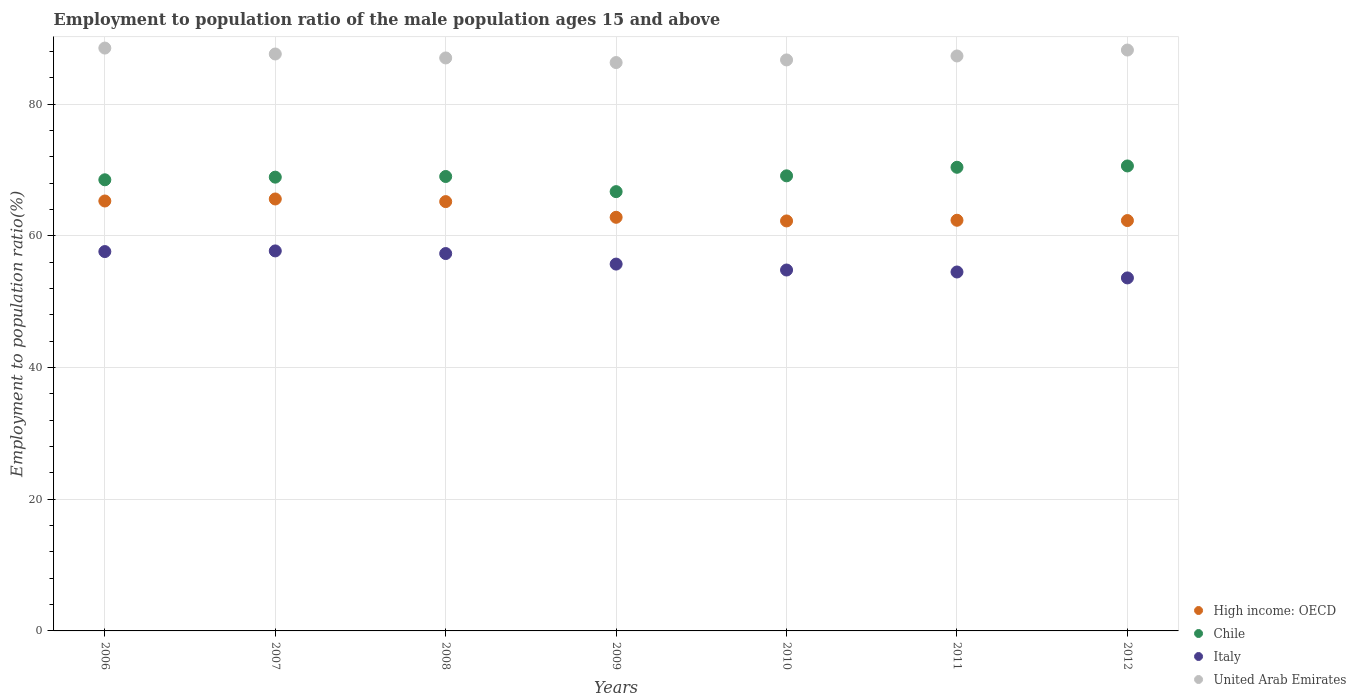Is the number of dotlines equal to the number of legend labels?
Offer a terse response. Yes. What is the employment to population ratio in High income: OECD in 2012?
Offer a very short reply. 62.31. Across all years, what is the maximum employment to population ratio in Italy?
Keep it short and to the point. 57.7. Across all years, what is the minimum employment to population ratio in Italy?
Offer a terse response. 53.6. What is the total employment to population ratio in Italy in the graph?
Ensure brevity in your answer.  391.2. What is the difference between the employment to population ratio in High income: OECD in 2007 and that in 2010?
Give a very brief answer. 3.33. What is the difference between the employment to population ratio in High income: OECD in 2009 and the employment to population ratio in United Arab Emirates in 2008?
Offer a terse response. -24.2. What is the average employment to population ratio in High income: OECD per year?
Give a very brief answer. 63.68. In the year 2012, what is the difference between the employment to population ratio in Italy and employment to population ratio in Chile?
Provide a short and direct response. -17. In how many years, is the employment to population ratio in Italy greater than 8 %?
Your response must be concise. 7. What is the ratio of the employment to population ratio in High income: OECD in 2007 to that in 2009?
Your response must be concise. 1.04. Is the difference between the employment to population ratio in Italy in 2009 and 2010 greater than the difference between the employment to population ratio in Chile in 2009 and 2010?
Give a very brief answer. Yes. What is the difference between the highest and the second highest employment to population ratio in Italy?
Keep it short and to the point. 0.1. What is the difference between the highest and the lowest employment to population ratio in High income: OECD?
Your answer should be compact. 3.33. Is the employment to population ratio in Italy strictly less than the employment to population ratio in United Arab Emirates over the years?
Your answer should be compact. Yes. How many dotlines are there?
Give a very brief answer. 4. How many years are there in the graph?
Make the answer very short. 7. What is the difference between two consecutive major ticks on the Y-axis?
Provide a short and direct response. 20. Are the values on the major ticks of Y-axis written in scientific E-notation?
Ensure brevity in your answer.  No. How many legend labels are there?
Your answer should be very brief. 4. What is the title of the graph?
Your response must be concise. Employment to population ratio of the male population ages 15 and above. Does "Netherlands" appear as one of the legend labels in the graph?
Your answer should be very brief. No. What is the label or title of the X-axis?
Ensure brevity in your answer.  Years. What is the label or title of the Y-axis?
Give a very brief answer. Employment to population ratio(%). What is the Employment to population ratio(%) in High income: OECD in 2006?
Offer a very short reply. 65.28. What is the Employment to population ratio(%) of Chile in 2006?
Provide a succinct answer. 68.5. What is the Employment to population ratio(%) in Italy in 2006?
Your answer should be compact. 57.6. What is the Employment to population ratio(%) of United Arab Emirates in 2006?
Make the answer very short. 88.5. What is the Employment to population ratio(%) in High income: OECD in 2007?
Your answer should be compact. 65.59. What is the Employment to population ratio(%) of Chile in 2007?
Provide a succinct answer. 68.9. What is the Employment to population ratio(%) of Italy in 2007?
Keep it short and to the point. 57.7. What is the Employment to population ratio(%) of United Arab Emirates in 2007?
Offer a terse response. 87.6. What is the Employment to population ratio(%) of High income: OECD in 2008?
Your answer should be very brief. 65.19. What is the Employment to population ratio(%) in Italy in 2008?
Offer a terse response. 57.3. What is the Employment to population ratio(%) in United Arab Emirates in 2008?
Make the answer very short. 87. What is the Employment to population ratio(%) of High income: OECD in 2009?
Offer a very short reply. 62.8. What is the Employment to population ratio(%) of Chile in 2009?
Give a very brief answer. 66.7. What is the Employment to population ratio(%) in Italy in 2009?
Offer a very short reply. 55.7. What is the Employment to population ratio(%) of United Arab Emirates in 2009?
Offer a very short reply. 86.3. What is the Employment to population ratio(%) of High income: OECD in 2010?
Provide a succinct answer. 62.25. What is the Employment to population ratio(%) of Chile in 2010?
Your answer should be compact. 69.1. What is the Employment to population ratio(%) in Italy in 2010?
Your response must be concise. 54.8. What is the Employment to population ratio(%) in United Arab Emirates in 2010?
Provide a succinct answer. 86.7. What is the Employment to population ratio(%) in High income: OECD in 2011?
Provide a short and direct response. 62.35. What is the Employment to population ratio(%) in Chile in 2011?
Ensure brevity in your answer.  70.4. What is the Employment to population ratio(%) in Italy in 2011?
Offer a very short reply. 54.5. What is the Employment to population ratio(%) in United Arab Emirates in 2011?
Ensure brevity in your answer.  87.3. What is the Employment to population ratio(%) in High income: OECD in 2012?
Give a very brief answer. 62.31. What is the Employment to population ratio(%) of Chile in 2012?
Provide a succinct answer. 70.6. What is the Employment to population ratio(%) in Italy in 2012?
Provide a succinct answer. 53.6. What is the Employment to population ratio(%) of United Arab Emirates in 2012?
Your response must be concise. 88.2. Across all years, what is the maximum Employment to population ratio(%) in High income: OECD?
Keep it short and to the point. 65.59. Across all years, what is the maximum Employment to population ratio(%) in Chile?
Provide a succinct answer. 70.6. Across all years, what is the maximum Employment to population ratio(%) in Italy?
Keep it short and to the point. 57.7. Across all years, what is the maximum Employment to population ratio(%) of United Arab Emirates?
Offer a very short reply. 88.5. Across all years, what is the minimum Employment to population ratio(%) in High income: OECD?
Make the answer very short. 62.25. Across all years, what is the minimum Employment to population ratio(%) of Chile?
Provide a succinct answer. 66.7. Across all years, what is the minimum Employment to population ratio(%) of Italy?
Make the answer very short. 53.6. Across all years, what is the minimum Employment to population ratio(%) in United Arab Emirates?
Your response must be concise. 86.3. What is the total Employment to population ratio(%) of High income: OECD in the graph?
Make the answer very short. 445.77. What is the total Employment to population ratio(%) of Chile in the graph?
Provide a succinct answer. 483.2. What is the total Employment to population ratio(%) in Italy in the graph?
Your answer should be very brief. 391.2. What is the total Employment to population ratio(%) of United Arab Emirates in the graph?
Keep it short and to the point. 611.6. What is the difference between the Employment to population ratio(%) in High income: OECD in 2006 and that in 2007?
Offer a terse response. -0.31. What is the difference between the Employment to population ratio(%) of Chile in 2006 and that in 2007?
Offer a very short reply. -0.4. What is the difference between the Employment to population ratio(%) in Italy in 2006 and that in 2007?
Offer a terse response. -0.1. What is the difference between the Employment to population ratio(%) of United Arab Emirates in 2006 and that in 2007?
Give a very brief answer. 0.9. What is the difference between the Employment to population ratio(%) in High income: OECD in 2006 and that in 2008?
Provide a succinct answer. 0.09. What is the difference between the Employment to population ratio(%) of High income: OECD in 2006 and that in 2009?
Give a very brief answer. 2.48. What is the difference between the Employment to population ratio(%) in Italy in 2006 and that in 2009?
Offer a very short reply. 1.9. What is the difference between the Employment to population ratio(%) in United Arab Emirates in 2006 and that in 2009?
Your response must be concise. 2.2. What is the difference between the Employment to population ratio(%) of High income: OECD in 2006 and that in 2010?
Keep it short and to the point. 3.03. What is the difference between the Employment to population ratio(%) of Italy in 2006 and that in 2010?
Your answer should be very brief. 2.8. What is the difference between the Employment to population ratio(%) of United Arab Emirates in 2006 and that in 2010?
Your response must be concise. 1.8. What is the difference between the Employment to population ratio(%) in High income: OECD in 2006 and that in 2011?
Your answer should be compact. 2.93. What is the difference between the Employment to population ratio(%) of Chile in 2006 and that in 2011?
Give a very brief answer. -1.9. What is the difference between the Employment to population ratio(%) of Italy in 2006 and that in 2011?
Your response must be concise. 3.1. What is the difference between the Employment to population ratio(%) in United Arab Emirates in 2006 and that in 2011?
Offer a very short reply. 1.2. What is the difference between the Employment to population ratio(%) in High income: OECD in 2006 and that in 2012?
Your answer should be very brief. 2.97. What is the difference between the Employment to population ratio(%) of Italy in 2006 and that in 2012?
Offer a very short reply. 4. What is the difference between the Employment to population ratio(%) of United Arab Emirates in 2006 and that in 2012?
Offer a terse response. 0.3. What is the difference between the Employment to population ratio(%) of High income: OECD in 2007 and that in 2008?
Offer a very short reply. 0.4. What is the difference between the Employment to population ratio(%) of Italy in 2007 and that in 2008?
Ensure brevity in your answer.  0.4. What is the difference between the Employment to population ratio(%) in United Arab Emirates in 2007 and that in 2008?
Your response must be concise. 0.6. What is the difference between the Employment to population ratio(%) of High income: OECD in 2007 and that in 2009?
Keep it short and to the point. 2.78. What is the difference between the Employment to population ratio(%) of Chile in 2007 and that in 2009?
Offer a terse response. 2.2. What is the difference between the Employment to population ratio(%) in High income: OECD in 2007 and that in 2010?
Provide a succinct answer. 3.33. What is the difference between the Employment to population ratio(%) of Italy in 2007 and that in 2010?
Your answer should be compact. 2.9. What is the difference between the Employment to population ratio(%) in United Arab Emirates in 2007 and that in 2010?
Offer a very short reply. 0.9. What is the difference between the Employment to population ratio(%) of High income: OECD in 2007 and that in 2011?
Give a very brief answer. 3.23. What is the difference between the Employment to population ratio(%) in United Arab Emirates in 2007 and that in 2011?
Ensure brevity in your answer.  0.3. What is the difference between the Employment to population ratio(%) in High income: OECD in 2007 and that in 2012?
Offer a very short reply. 3.28. What is the difference between the Employment to population ratio(%) in Chile in 2007 and that in 2012?
Keep it short and to the point. -1.7. What is the difference between the Employment to population ratio(%) in United Arab Emirates in 2007 and that in 2012?
Your answer should be very brief. -0.6. What is the difference between the Employment to population ratio(%) in High income: OECD in 2008 and that in 2009?
Keep it short and to the point. 2.38. What is the difference between the Employment to population ratio(%) of High income: OECD in 2008 and that in 2010?
Provide a short and direct response. 2.94. What is the difference between the Employment to population ratio(%) of Italy in 2008 and that in 2010?
Your response must be concise. 2.5. What is the difference between the Employment to population ratio(%) in High income: OECD in 2008 and that in 2011?
Your answer should be compact. 2.83. What is the difference between the Employment to population ratio(%) in Chile in 2008 and that in 2011?
Give a very brief answer. -1.4. What is the difference between the Employment to population ratio(%) of Italy in 2008 and that in 2011?
Make the answer very short. 2.8. What is the difference between the Employment to population ratio(%) in United Arab Emirates in 2008 and that in 2011?
Your response must be concise. -0.3. What is the difference between the Employment to population ratio(%) of High income: OECD in 2008 and that in 2012?
Make the answer very short. 2.88. What is the difference between the Employment to population ratio(%) of Chile in 2008 and that in 2012?
Give a very brief answer. -1.6. What is the difference between the Employment to population ratio(%) in High income: OECD in 2009 and that in 2010?
Offer a terse response. 0.55. What is the difference between the Employment to population ratio(%) in Italy in 2009 and that in 2010?
Provide a short and direct response. 0.9. What is the difference between the Employment to population ratio(%) of High income: OECD in 2009 and that in 2011?
Give a very brief answer. 0.45. What is the difference between the Employment to population ratio(%) of High income: OECD in 2009 and that in 2012?
Ensure brevity in your answer.  0.5. What is the difference between the Employment to population ratio(%) of Chile in 2009 and that in 2012?
Ensure brevity in your answer.  -3.9. What is the difference between the Employment to population ratio(%) in High income: OECD in 2010 and that in 2011?
Keep it short and to the point. -0.1. What is the difference between the Employment to population ratio(%) in High income: OECD in 2010 and that in 2012?
Your answer should be compact. -0.06. What is the difference between the Employment to population ratio(%) in Chile in 2010 and that in 2012?
Provide a succinct answer. -1.5. What is the difference between the Employment to population ratio(%) in High income: OECD in 2011 and that in 2012?
Offer a terse response. 0.04. What is the difference between the Employment to population ratio(%) of Italy in 2011 and that in 2012?
Your response must be concise. 0.9. What is the difference between the Employment to population ratio(%) in High income: OECD in 2006 and the Employment to population ratio(%) in Chile in 2007?
Give a very brief answer. -3.62. What is the difference between the Employment to population ratio(%) of High income: OECD in 2006 and the Employment to population ratio(%) of Italy in 2007?
Offer a terse response. 7.58. What is the difference between the Employment to population ratio(%) in High income: OECD in 2006 and the Employment to population ratio(%) in United Arab Emirates in 2007?
Offer a very short reply. -22.32. What is the difference between the Employment to population ratio(%) in Chile in 2006 and the Employment to population ratio(%) in United Arab Emirates in 2007?
Your response must be concise. -19.1. What is the difference between the Employment to population ratio(%) of High income: OECD in 2006 and the Employment to population ratio(%) of Chile in 2008?
Keep it short and to the point. -3.72. What is the difference between the Employment to population ratio(%) of High income: OECD in 2006 and the Employment to population ratio(%) of Italy in 2008?
Keep it short and to the point. 7.98. What is the difference between the Employment to population ratio(%) in High income: OECD in 2006 and the Employment to population ratio(%) in United Arab Emirates in 2008?
Give a very brief answer. -21.72. What is the difference between the Employment to population ratio(%) of Chile in 2006 and the Employment to population ratio(%) of United Arab Emirates in 2008?
Give a very brief answer. -18.5. What is the difference between the Employment to population ratio(%) in Italy in 2006 and the Employment to population ratio(%) in United Arab Emirates in 2008?
Your response must be concise. -29.4. What is the difference between the Employment to population ratio(%) in High income: OECD in 2006 and the Employment to population ratio(%) in Chile in 2009?
Your answer should be very brief. -1.42. What is the difference between the Employment to population ratio(%) in High income: OECD in 2006 and the Employment to population ratio(%) in Italy in 2009?
Provide a succinct answer. 9.58. What is the difference between the Employment to population ratio(%) in High income: OECD in 2006 and the Employment to population ratio(%) in United Arab Emirates in 2009?
Offer a very short reply. -21.02. What is the difference between the Employment to population ratio(%) of Chile in 2006 and the Employment to population ratio(%) of United Arab Emirates in 2009?
Offer a very short reply. -17.8. What is the difference between the Employment to population ratio(%) of Italy in 2006 and the Employment to population ratio(%) of United Arab Emirates in 2009?
Offer a very short reply. -28.7. What is the difference between the Employment to population ratio(%) of High income: OECD in 2006 and the Employment to population ratio(%) of Chile in 2010?
Offer a very short reply. -3.82. What is the difference between the Employment to population ratio(%) of High income: OECD in 2006 and the Employment to population ratio(%) of Italy in 2010?
Give a very brief answer. 10.48. What is the difference between the Employment to population ratio(%) in High income: OECD in 2006 and the Employment to population ratio(%) in United Arab Emirates in 2010?
Your answer should be compact. -21.42. What is the difference between the Employment to population ratio(%) in Chile in 2006 and the Employment to population ratio(%) in Italy in 2010?
Your answer should be very brief. 13.7. What is the difference between the Employment to population ratio(%) of Chile in 2006 and the Employment to population ratio(%) of United Arab Emirates in 2010?
Your answer should be compact. -18.2. What is the difference between the Employment to population ratio(%) of Italy in 2006 and the Employment to population ratio(%) of United Arab Emirates in 2010?
Make the answer very short. -29.1. What is the difference between the Employment to population ratio(%) in High income: OECD in 2006 and the Employment to population ratio(%) in Chile in 2011?
Give a very brief answer. -5.12. What is the difference between the Employment to population ratio(%) in High income: OECD in 2006 and the Employment to population ratio(%) in Italy in 2011?
Offer a very short reply. 10.78. What is the difference between the Employment to population ratio(%) of High income: OECD in 2006 and the Employment to population ratio(%) of United Arab Emirates in 2011?
Your response must be concise. -22.02. What is the difference between the Employment to population ratio(%) of Chile in 2006 and the Employment to population ratio(%) of Italy in 2011?
Offer a terse response. 14. What is the difference between the Employment to population ratio(%) in Chile in 2006 and the Employment to population ratio(%) in United Arab Emirates in 2011?
Offer a very short reply. -18.8. What is the difference between the Employment to population ratio(%) of Italy in 2006 and the Employment to population ratio(%) of United Arab Emirates in 2011?
Make the answer very short. -29.7. What is the difference between the Employment to population ratio(%) of High income: OECD in 2006 and the Employment to population ratio(%) of Chile in 2012?
Keep it short and to the point. -5.32. What is the difference between the Employment to population ratio(%) of High income: OECD in 2006 and the Employment to population ratio(%) of Italy in 2012?
Make the answer very short. 11.68. What is the difference between the Employment to population ratio(%) of High income: OECD in 2006 and the Employment to population ratio(%) of United Arab Emirates in 2012?
Provide a short and direct response. -22.92. What is the difference between the Employment to population ratio(%) in Chile in 2006 and the Employment to population ratio(%) in United Arab Emirates in 2012?
Offer a terse response. -19.7. What is the difference between the Employment to population ratio(%) in Italy in 2006 and the Employment to population ratio(%) in United Arab Emirates in 2012?
Ensure brevity in your answer.  -30.6. What is the difference between the Employment to population ratio(%) of High income: OECD in 2007 and the Employment to population ratio(%) of Chile in 2008?
Offer a terse response. -3.41. What is the difference between the Employment to population ratio(%) of High income: OECD in 2007 and the Employment to population ratio(%) of Italy in 2008?
Make the answer very short. 8.29. What is the difference between the Employment to population ratio(%) of High income: OECD in 2007 and the Employment to population ratio(%) of United Arab Emirates in 2008?
Your response must be concise. -21.41. What is the difference between the Employment to population ratio(%) of Chile in 2007 and the Employment to population ratio(%) of Italy in 2008?
Make the answer very short. 11.6. What is the difference between the Employment to population ratio(%) in Chile in 2007 and the Employment to population ratio(%) in United Arab Emirates in 2008?
Provide a short and direct response. -18.1. What is the difference between the Employment to population ratio(%) of Italy in 2007 and the Employment to population ratio(%) of United Arab Emirates in 2008?
Offer a very short reply. -29.3. What is the difference between the Employment to population ratio(%) in High income: OECD in 2007 and the Employment to population ratio(%) in Chile in 2009?
Provide a succinct answer. -1.11. What is the difference between the Employment to population ratio(%) in High income: OECD in 2007 and the Employment to population ratio(%) in Italy in 2009?
Offer a terse response. 9.89. What is the difference between the Employment to population ratio(%) in High income: OECD in 2007 and the Employment to population ratio(%) in United Arab Emirates in 2009?
Keep it short and to the point. -20.71. What is the difference between the Employment to population ratio(%) in Chile in 2007 and the Employment to population ratio(%) in Italy in 2009?
Keep it short and to the point. 13.2. What is the difference between the Employment to population ratio(%) of Chile in 2007 and the Employment to population ratio(%) of United Arab Emirates in 2009?
Offer a terse response. -17.4. What is the difference between the Employment to population ratio(%) of Italy in 2007 and the Employment to population ratio(%) of United Arab Emirates in 2009?
Your response must be concise. -28.6. What is the difference between the Employment to population ratio(%) in High income: OECD in 2007 and the Employment to population ratio(%) in Chile in 2010?
Give a very brief answer. -3.51. What is the difference between the Employment to population ratio(%) of High income: OECD in 2007 and the Employment to population ratio(%) of Italy in 2010?
Give a very brief answer. 10.79. What is the difference between the Employment to population ratio(%) in High income: OECD in 2007 and the Employment to population ratio(%) in United Arab Emirates in 2010?
Make the answer very short. -21.11. What is the difference between the Employment to population ratio(%) in Chile in 2007 and the Employment to population ratio(%) in United Arab Emirates in 2010?
Provide a succinct answer. -17.8. What is the difference between the Employment to population ratio(%) in High income: OECD in 2007 and the Employment to population ratio(%) in Chile in 2011?
Keep it short and to the point. -4.81. What is the difference between the Employment to population ratio(%) of High income: OECD in 2007 and the Employment to population ratio(%) of Italy in 2011?
Ensure brevity in your answer.  11.09. What is the difference between the Employment to population ratio(%) of High income: OECD in 2007 and the Employment to population ratio(%) of United Arab Emirates in 2011?
Give a very brief answer. -21.71. What is the difference between the Employment to population ratio(%) in Chile in 2007 and the Employment to population ratio(%) in United Arab Emirates in 2011?
Give a very brief answer. -18.4. What is the difference between the Employment to population ratio(%) of Italy in 2007 and the Employment to population ratio(%) of United Arab Emirates in 2011?
Your answer should be compact. -29.6. What is the difference between the Employment to population ratio(%) of High income: OECD in 2007 and the Employment to population ratio(%) of Chile in 2012?
Offer a very short reply. -5.01. What is the difference between the Employment to population ratio(%) of High income: OECD in 2007 and the Employment to population ratio(%) of Italy in 2012?
Provide a short and direct response. 11.99. What is the difference between the Employment to population ratio(%) in High income: OECD in 2007 and the Employment to population ratio(%) in United Arab Emirates in 2012?
Your answer should be very brief. -22.61. What is the difference between the Employment to population ratio(%) in Chile in 2007 and the Employment to population ratio(%) in United Arab Emirates in 2012?
Keep it short and to the point. -19.3. What is the difference between the Employment to population ratio(%) in Italy in 2007 and the Employment to population ratio(%) in United Arab Emirates in 2012?
Keep it short and to the point. -30.5. What is the difference between the Employment to population ratio(%) in High income: OECD in 2008 and the Employment to population ratio(%) in Chile in 2009?
Offer a very short reply. -1.51. What is the difference between the Employment to population ratio(%) in High income: OECD in 2008 and the Employment to population ratio(%) in Italy in 2009?
Your answer should be compact. 9.49. What is the difference between the Employment to population ratio(%) in High income: OECD in 2008 and the Employment to population ratio(%) in United Arab Emirates in 2009?
Your answer should be very brief. -21.11. What is the difference between the Employment to population ratio(%) in Chile in 2008 and the Employment to population ratio(%) in United Arab Emirates in 2009?
Your answer should be very brief. -17.3. What is the difference between the Employment to population ratio(%) in Italy in 2008 and the Employment to population ratio(%) in United Arab Emirates in 2009?
Make the answer very short. -29. What is the difference between the Employment to population ratio(%) of High income: OECD in 2008 and the Employment to population ratio(%) of Chile in 2010?
Provide a short and direct response. -3.91. What is the difference between the Employment to population ratio(%) in High income: OECD in 2008 and the Employment to population ratio(%) in Italy in 2010?
Your response must be concise. 10.39. What is the difference between the Employment to population ratio(%) in High income: OECD in 2008 and the Employment to population ratio(%) in United Arab Emirates in 2010?
Provide a short and direct response. -21.51. What is the difference between the Employment to population ratio(%) in Chile in 2008 and the Employment to population ratio(%) in United Arab Emirates in 2010?
Ensure brevity in your answer.  -17.7. What is the difference between the Employment to population ratio(%) in Italy in 2008 and the Employment to population ratio(%) in United Arab Emirates in 2010?
Your answer should be compact. -29.4. What is the difference between the Employment to population ratio(%) of High income: OECD in 2008 and the Employment to population ratio(%) of Chile in 2011?
Make the answer very short. -5.21. What is the difference between the Employment to population ratio(%) of High income: OECD in 2008 and the Employment to population ratio(%) of Italy in 2011?
Your response must be concise. 10.69. What is the difference between the Employment to population ratio(%) of High income: OECD in 2008 and the Employment to population ratio(%) of United Arab Emirates in 2011?
Offer a terse response. -22.11. What is the difference between the Employment to population ratio(%) in Chile in 2008 and the Employment to population ratio(%) in United Arab Emirates in 2011?
Make the answer very short. -18.3. What is the difference between the Employment to population ratio(%) of High income: OECD in 2008 and the Employment to population ratio(%) of Chile in 2012?
Your response must be concise. -5.41. What is the difference between the Employment to population ratio(%) in High income: OECD in 2008 and the Employment to population ratio(%) in Italy in 2012?
Make the answer very short. 11.59. What is the difference between the Employment to population ratio(%) of High income: OECD in 2008 and the Employment to population ratio(%) of United Arab Emirates in 2012?
Offer a very short reply. -23.01. What is the difference between the Employment to population ratio(%) in Chile in 2008 and the Employment to population ratio(%) in United Arab Emirates in 2012?
Offer a terse response. -19.2. What is the difference between the Employment to population ratio(%) of Italy in 2008 and the Employment to population ratio(%) of United Arab Emirates in 2012?
Offer a terse response. -30.9. What is the difference between the Employment to population ratio(%) of High income: OECD in 2009 and the Employment to population ratio(%) of Chile in 2010?
Your answer should be compact. -6.3. What is the difference between the Employment to population ratio(%) in High income: OECD in 2009 and the Employment to population ratio(%) in Italy in 2010?
Your response must be concise. 8. What is the difference between the Employment to population ratio(%) in High income: OECD in 2009 and the Employment to population ratio(%) in United Arab Emirates in 2010?
Offer a very short reply. -23.9. What is the difference between the Employment to population ratio(%) in Chile in 2009 and the Employment to population ratio(%) in Italy in 2010?
Your response must be concise. 11.9. What is the difference between the Employment to population ratio(%) of Italy in 2009 and the Employment to population ratio(%) of United Arab Emirates in 2010?
Your response must be concise. -31. What is the difference between the Employment to population ratio(%) of High income: OECD in 2009 and the Employment to population ratio(%) of Chile in 2011?
Ensure brevity in your answer.  -7.6. What is the difference between the Employment to population ratio(%) of High income: OECD in 2009 and the Employment to population ratio(%) of Italy in 2011?
Offer a terse response. 8.3. What is the difference between the Employment to population ratio(%) of High income: OECD in 2009 and the Employment to population ratio(%) of United Arab Emirates in 2011?
Your response must be concise. -24.5. What is the difference between the Employment to population ratio(%) of Chile in 2009 and the Employment to population ratio(%) of Italy in 2011?
Give a very brief answer. 12.2. What is the difference between the Employment to population ratio(%) of Chile in 2009 and the Employment to population ratio(%) of United Arab Emirates in 2011?
Provide a short and direct response. -20.6. What is the difference between the Employment to population ratio(%) of Italy in 2009 and the Employment to population ratio(%) of United Arab Emirates in 2011?
Provide a short and direct response. -31.6. What is the difference between the Employment to population ratio(%) in High income: OECD in 2009 and the Employment to population ratio(%) in Chile in 2012?
Keep it short and to the point. -7.8. What is the difference between the Employment to population ratio(%) of High income: OECD in 2009 and the Employment to population ratio(%) of Italy in 2012?
Your answer should be very brief. 9.2. What is the difference between the Employment to population ratio(%) of High income: OECD in 2009 and the Employment to population ratio(%) of United Arab Emirates in 2012?
Keep it short and to the point. -25.4. What is the difference between the Employment to population ratio(%) in Chile in 2009 and the Employment to population ratio(%) in Italy in 2012?
Provide a succinct answer. 13.1. What is the difference between the Employment to population ratio(%) of Chile in 2009 and the Employment to population ratio(%) of United Arab Emirates in 2012?
Keep it short and to the point. -21.5. What is the difference between the Employment to population ratio(%) in Italy in 2009 and the Employment to population ratio(%) in United Arab Emirates in 2012?
Offer a very short reply. -32.5. What is the difference between the Employment to population ratio(%) in High income: OECD in 2010 and the Employment to population ratio(%) in Chile in 2011?
Your answer should be very brief. -8.15. What is the difference between the Employment to population ratio(%) in High income: OECD in 2010 and the Employment to population ratio(%) in Italy in 2011?
Provide a succinct answer. 7.75. What is the difference between the Employment to population ratio(%) in High income: OECD in 2010 and the Employment to population ratio(%) in United Arab Emirates in 2011?
Keep it short and to the point. -25.05. What is the difference between the Employment to population ratio(%) in Chile in 2010 and the Employment to population ratio(%) in United Arab Emirates in 2011?
Make the answer very short. -18.2. What is the difference between the Employment to population ratio(%) in Italy in 2010 and the Employment to population ratio(%) in United Arab Emirates in 2011?
Offer a very short reply. -32.5. What is the difference between the Employment to population ratio(%) in High income: OECD in 2010 and the Employment to population ratio(%) in Chile in 2012?
Your response must be concise. -8.35. What is the difference between the Employment to population ratio(%) in High income: OECD in 2010 and the Employment to population ratio(%) in Italy in 2012?
Offer a very short reply. 8.65. What is the difference between the Employment to population ratio(%) in High income: OECD in 2010 and the Employment to population ratio(%) in United Arab Emirates in 2012?
Make the answer very short. -25.95. What is the difference between the Employment to population ratio(%) of Chile in 2010 and the Employment to population ratio(%) of United Arab Emirates in 2012?
Provide a succinct answer. -19.1. What is the difference between the Employment to population ratio(%) in Italy in 2010 and the Employment to population ratio(%) in United Arab Emirates in 2012?
Offer a very short reply. -33.4. What is the difference between the Employment to population ratio(%) of High income: OECD in 2011 and the Employment to population ratio(%) of Chile in 2012?
Give a very brief answer. -8.25. What is the difference between the Employment to population ratio(%) in High income: OECD in 2011 and the Employment to population ratio(%) in Italy in 2012?
Provide a short and direct response. 8.75. What is the difference between the Employment to population ratio(%) of High income: OECD in 2011 and the Employment to population ratio(%) of United Arab Emirates in 2012?
Give a very brief answer. -25.85. What is the difference between the Employment to population ratio(%) of Chile in 2011 and the Employment to population ratio(%) of United Arab Emirates in 2012?
Your answer should be very brief. -17.8. What is the difference between the Employment to population ratio(%) in Italy in 2011 and the Employment to population ratio(%) in United Arab Emirates in 2012?
Your answer should be very brief. -33.7. What is the average Employment to population ratio(%) in High income: OECD per year?
Your answer should be compact. 63.68. What is the average Employment to population ratio(%) in Chile per year?
Your response must be concise. 69.03. What is the average Employment to population ratio(%) of Italy per year?
Offer a very short reply. 55.89. What is the average Employment to population ratio(%) of United Arab Emirates per year?
Offer a very short reply. 87.37. In the year 2006, what is the difference between the Employment to population ratio(%) in High income: OECD and Employment to population ratio(%) in Chile?
Offer a very short reply. -3.22. In the year 2006, what is the difference between the Employment to population ratio(%) in High income: OECD and Employment to population ratio(%) in Italy?
Give a very brief answer. 7.68. In the year 2006, what is the difference between the Employment to population ratio(%) of High income: OECD and Employment to population ratio(%) of United Arab Emirates?
Give a very brief answer. -23.22. In the year 2006, what is the difference between the Employment to population ratio(%) of Chile and Employment to population ratio(%) of United Arab Emirates?
Ensure brevity in your answer.  -20. In the year 2006, what is the difference between the Employment to population ratio(%) of Italy and Employment to population ratio(%) of United Arab Emirates?
Keep it short and to the point. -30.9. In the year 2007, what is the difference between the Employment to population ratio(%) of High income: OECD and Employment to population ratio(%) of Chile?
Your answer should be very brief. -3.31. In the year 2007, what is the difference between the Employment to population ratio(%) of High income: OECD and Employment to population ratio(%) of Italy?
Your answer should be compact. 7.89. In the year 2007, what is the difference between the Employment to population ratio(%) of High income: OECD and Employment to population ratio(%) of United Arab Emirates?
Your answer should be very brief. -22.01. In the year 2007, what is the difference between the Employment to population ratio(%) in Chile and Employment to population ratio(%) in United Arab Emirates?
Offer a terse response. -18.7. In the year 2007, what is the difference between the Employment to population ratio(%) in Italy and Employment to population ratio(%) in United Arab Emirates?
Make the answer very short. -29.9. In the year 2008, what is the difference between the Employment to population ratio(%) in High income: OECD and Employment to population ratio(%) in Chile?
Your answer should be compact. -3.81. In the year 2008, what is the difference between the Employment to population ratio(%) of High income: OECD and Employment to population ratio(%) of Italy?
Your response must be concise. 7.89. In the year 2008, what is the difference between the Employment to population ratio(%) in High income: OECD and Employment to population ratio(%) in United Arab Emirates?
Provide a short and direct response. -21.81. In the year 2008, what is the difference between the Employment to population ratio(%) in Chile and Employment to population ratio(%) in Italy?
Offer a terse response. 11.7. In the year 2008, what is the difference between the Employment to population ratio(%) of Italy and Employment to population ratio(%) of United Arab Emirates?
Your answer should be very brief. -29.7. In the year 2009, what is the difference between the Employment to population ratio(%) in High income: OECD and Employment to population ratio(%) in Chile?
Offer a terse response. -3.9. In the year 2009, what is the difference between the Employment to population ratio(%) of High income: OECD and Employment to population ratio(%) of Italy?
Keep it short and to the point. 7.1. In the year 2009, what is the difference between the Employment to population ratio(%) of High income: OECD and Employment to population ratio(%) of United Arab Emirates?
Ensure brevity in your answer.  -23.5. In the year 2009, what is the difference between the Employment to population ratio(%) of Chile and Employment to population ratio(%) of United Arab Emirates?
Provide a succinct answer. -19.6. In the year 2009, what is the difference between the Employment to population ratio(%) in Italy and Employment to population ratio(%) in United Arab Emirates?
Give a very brief answer. -30.6. In the year 2010, what is the difference between the Employment to population ratio(%) of High income: OECD and Employment to population ratio(%) of Chile?
Make the answer very short. -6.85. In the year 2010, what is the difference between the Employment to population ratio(%) of High income: OECD and Employment to population ratio(%) of Italy?
Offer a very short reply. 7.45. In the year 2010, what is the difference between the Employment to population ratio(%) in High income: OECD and Employment to population ratio(%) in United Arab Emirates?
Your response must be concise. -24.45. In the year 2010, what is the difference between the Employment to population ratio(%) in Chile and Employment to population ratio(%) in Italy?
Your answer should be very brief. 14.3. In the year 2010, what is the difference between the Employment to population ratio(%) in Chile and Employment to population ratio(%) in United Arab Emirates?
Offer a very short reply. -17.6. In the year 2010, what is the difference between the Employment to population ratio(%) of Italy and Employment to population ratio(%) of United Arab Emirates?
Provide a succinct answer. -31.9. In the year 2011, what is the difference between the Employment to population ratio(%) of High income: OECD and Employment to population ratio(%) of Chile?
Your answer should be compact. -8.05. In the year 2011, what is the difference between the Employment to population ratio(%) in High income: OECD and Employment to population ratio(%) in Italy?
Give a very brief answer. 7.85. In the year 2011, what is the difference between the Employment to population ratio(%) of High income: OECD and Employment to population ratio(%) of United Arab Emirates?
Offer a very short reply. -24.95. In the year 2011, what is the difference between the Employment to population ratio(%) in Chile and Employment to population ratio(%) in United Arab Emirates?
Your answer should be very brief. -16.9. In the year 2011, what is the difference between the Employment to population ratio(%) of Italy and Employment to population ratio(%) of United Arab Emirates?
Ensure brevity in your answer.  -32.8. In the year 2012, what is the difference between the Employment to population ratio(%) in High income: OECD and Employment to population ratio(%) in Chile?
Offer a terse response. -8.29. In the year 2012, what is the difference between the Employment to population ratio(%) of High income: OECD and Employment to population ratio(%) of Italy?
Provide a short and direct response. 8.71. In the year 2012, what is the difference between the Employment to population ratio(%) in High income: OECD and Employment to population ratio(%) in United Arab Emirates?
Make the answer very short. -25.89. In the year 2012, what is the difference between the Employment to population ratio(%) in Chile and Employment to population ratio(%) in United Arab Emirates?
Ensure brevity in your answer.  -17.6. In the year 2012, what is the difference between the Employment to population ratio(%) in Italy and Employment to population ratio(%) in United Arab Emirates?
Give a very brief answer. -34.6. What is the ratio of the Employment to population ratio(%) of Chile in 2006 to that in 2007?
Your answer should be compact. 0.99. What is the ratio of the Employment to population ratio(%) of United Arab Emirates in 2006 to that in 2007?
Your answer should be very brief. 1.01. What is the ratio of the Employment to population ratio(%) in High income: OECD in 2006 to that in 2008?
Your answer should be compact. 1. What is the ratio of the Employment to population ratio(%) in Chile in 2006 to that in 2008?
Offer a very short reply. 0.99. What is the ratio of the Employment to population ratio(%) of Italy in 2006 to that in 2008?
Provide a succinct answer. 1.01. What is the ratio of the Employment to population ratio(%) in United Arab Emirates in 2006 to that in 2008?
Offer a very short reply. 1.02. What is the ratio of the Employment to population ratio(%) in High income: OECD in 2006 to that in 2009?
Provide a succinct answer. 1.04. What is the ratio of the Employment to population ratio(%) in Chile in 2006 to that in 2009?
Your answer should be very brief. 1.03. What is the ratio of the Employment to population ratio(%) of Italy in 2006 to that in 2009?
Your answer should be compact. 1.03. What is the ratio of the Employment to population ratio(%) of United Arab Emirates in 2006 to that in 2009?
Make the answer very short. 1.03. What is the ratio of the Employment to population ratio(%) of High income: OECD in 2006 to that in 2010?
Keep it short and to the point. 1.05. What is the ratio of the Employment to population ratio(%) of Italy in 2006 to that in 2010?
Offer a terse response. 1.05. What is the ratio of the Employment to population ratio(%) of United Arab Emirates in 2006 to that in 2010?
Ensure brevity in your answer.  1.02. What is the ratio of the Employment to population ratio(%) of High income: OECD in 2006 to that in 2011?
Ensure brevity in your answer.  1.05. What is the ratio of the Employment to population ratio(%) of Chile in 2006 to that in 2011?
Keep it short and to the point. 0.97. What is the ratio of the Employment to population ratio(%) in Italy in 2006 to that in 2011?
Make the answer very short. 1.06. What is the ratio of the Employment to population ratio(%) of United Arab Emirates in 2006 to that in 2011?
Ensure brevity in your answer.  1.01. What is the ratio of the Employment to population ratio(%) in High income: OECD in 2006 to that in 2012?
Keep it short and to the point. 1.05. What is the ratio of the Employment to population ratio(%) in Chile in 2006 to that in 2012?
Your response must be concise. 0.97. What is the ratio of the Employment to population ratio(%) of Italy in 2006 to that in 2012?
Your response must be concise. 1.07. What is the ratio of the Employment to population ratio(%) in United Arab Emirates in 2006 to that in 2012?
Make the answer very short. 1. What is the ratio of the Employment to population ratio(%) in United Arab Emirates in 2007 to that in 2008?
Keep it short and to the point. 1.01. What is the ratio of the Employment to population ratio(%) of High income: OECD in 2007 to that in 2009?
Provide a short and direct response. 1.04. What is the ratio of the Employment to population ratio(%) in Chile in 2007 to that in 2009?
Make the answer very short. 1.03. What is the ratio of the Employment to population ratio(%) in Italy in 2007 to that in 2009?
Make the answer very short. 1.04. What is the ratio of the Employment to population ratio(%) of United Arab Emirates in 2007 to that in 2009?
Your response must be concise. 1.02. What is the ratio of the Employment to population ratio(%) of High income: OECD in 2007 to that in 2010?
Your answer should be very brief. 1.05. What is the ratio of the Employment to population ratio(%) in Chile in 2007 to that in 2010?
Make the answer very short. 1. What is the ratio of the Employment to population ratio(%) of Italy in 2007 to that in 2010?
Make the answer very short. 1.05. What is the ratio of the Employment to population ratio(%) in United Arab Emirates in 2007 to that in 2010?
Provide a short and direct response. 1.01. What is the ratio of the Employment to population ratio(%) in High income: OECD in 2007 to that in 2011?
Offer a terse response. 1.05. What is the ratio of the Employment to population ratio(%) of Chile in 2007 to that in 2011?
Ensure brevity in your answer.  0.98. What is the ratio of the Employment to population ratio(%) of Italy in 2007 to that in 2011?
Offer a terse response. 1.06. What is the ratio of the Employment to population ratio(%) in United Arab Emirates in 2007 to that in 2011?
Give a very brief answer. 1. What is the ratio of the Employment to population ratio(%) of High income: OECD in 2007 to that in 2012?
Keep it short and to the point. 1.05. What is the ratio of the Employment to population ratio(%) in Chile in 2007 to that in 2012?
Make the answer very short. 0.98. What is the ratio of the Employment to population ratio(%) of Italy in 2007 to that in 2012?
Keep it short and to the point. 1.08. What is the ratio of the Employment to population ratio(%) of United Arab Emirates in 2007 to that in 2012?
Provide a short and direct response. 0.99. What is the ratio of the Employment to population ratio(%) of High income: OECD in 2008 to that in 2009?
Offer a very short reply. 1.04. What is the ratio of the Employment to population ratio(%) of Chile in 2008 to that in 2009?
Your answer should be very brief. 1.03. What is the ratio of the Employment to population ratio(%) in Italy in 2008 to that in 2009?
Keep it short and to the point. 1.03. What is the ratio of the Employment to population ratio(%) of High income: OECD in 2008 to that in 2010?
Make the answer very short. 1.05. What is the ratio of the Employment to population ratio(%) of Chile in 2008 to that in 2010?
Provide a short and direct response. 1. What is the ratio of the Employment to population ratio(%) in Italy in 2008 to that in 2010?
Your answer should be very brief. 1.05. What is the ratio of the Employment to population ratio(%) of United Arab Emirates in 2008 to that in 2010?
Ensure brevity in your answer.  1. What is the ratio of the Employment to population ratio(%) in High income: OECD in 2008 to that in 2011?
Ensure brevity in your answer.  1.05. What is the ratio of the Employment to population ratio(%) of Chile in 2008 to that in 2011?
Provide a short and direct response. 0.98. What is the ratio of the Employment to population ratio(%) in Italy in 2008 to that in 2011?
Your answer should be very brief. 1.05. What is the ratio of the Employment to population ratio(%) in United Arab Emirates in 2008 to that in 2011?
Offer a very short reply. 1. What is the ratio of the Employment to population ratio(%) of High income: OECD in 2008 to that in 2012?
Give a very brief answer. 1.05. What is the ratio of the Employment to population ratio(%) of Chile in 2008 to that in 2012?
Offer a very short reply. 0.98. What is the ratio of the Employment to population ratio(%) of Italy in 2008 to that in 2012?
Make the answer very short. 1.07. What is the ratio of the Employment to population ratio(%) in United Arab Emirates in 2008 to that in 2012?
Ensure brevity in your answer.  0.99. What is the ratio of the Employment to population ratio(%) of High income: OECD in 2009 to that in 2010?
Offer a terse response. 1.01. What is the ratio of the Employment to population ratio(%) in Chile in 2009 to that in 2010?
Make the answer very short. 0.97. What is the ratio of the Employment to population ratio(%) of Italy in 2009 to that in 2010?
Keep it short and to the point. 1.02. What is the ratio of the Employment to population ratio(%) of United Arab Emirates in 2009 to that in 2011?
Your answer should be very brief. 0.99. What is the ratio of the Employment to population ratio(%) of High income: OECD in 2009 to that in 2012?
Offer a very short reply. 1.01. What is the ratio of the Employment to population ratio(%) in Chile in 2009 to that in 2012?
Your answer should be compact. 0.94. What is the ratio of the Employment to population ratio(%) in Italy in 2009 to that in 2012?
Your answer should be very brief. 1.04. What is the ratio of the Employment to population ratio(%) of United Arab Emirates in 2009 to that in 2012?
Offer a very short reply. 0.98. What is the ratio of the Employment to population ratio(%) in Chile in 2010 to that in 2011?
Provide a short and direct response. 0.98. What is the ratio of the Employment to population ratio(%) in Chile in 2010 to that in 2012?
Your response must be concise. 0.98. What is the ratio of the Employment to population ratio(%) of Italy in 2010 to that in 2012?
Offer a terse response. 1.02. What is the ratio of the Employment to population ratio(%) in High income: OECD in 2011 to that in 2012?
Your answer should be very brief. 1. What is the ratio of the Employment to population ratio(%) of Italy in 2011 to that in 2012?
Offer a very short reply. 1.02. What is the difference between the highest and the second highest Employment to population ratio(%) of High income: OECD?
Provide a succinct answer. 0.31. What is the difference between the highest and the second highest Employment to population ratio(%) in Chile?
Ensure brevity in your answer.  0.2. What is the difference between the highest and the second highest Employment to population ratio(%) of Italy?
Your answer should be very brief. 0.1. What is the difference between the highest and the second highest Employment to population ratio(%) of United Arab Emirates?
Provide a short and direct response. 0.3. What is the difference between the highest and the lowest Employment to population ratio(%) of High income: OECD?
Provide a short and direct response. 3.33. What is the difference between the highest and the lowest Employment to population ratio(%) in Chile?
Provide a short and direct response. 3.9. What is the difference between the highest and the lowest Employment to population ratio(%) in Italy?
Provide a succinct answer. 4.1. What is the difference between the highest and the lowest Employment to population ratio(%) of United Arab Emirates?
Give a very brief answer. 2.2. 